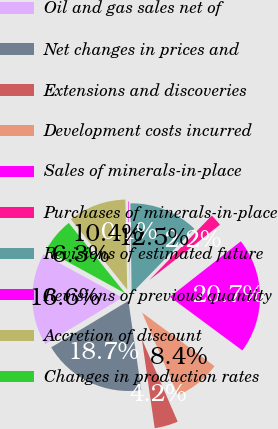Convert chart to OTSL. <chart><loc_0><loc_0><loc_500><loc_500><pie_chart><fcel>Oil and gas sales net of<fcel>Net changes in prices and<fcel>Extensions and discoveries<fcel>Development costs incurred<fcel>Sales of minerals-in-place<fcel>Purchases of minerals-in-place<fcel>Revisions of estimated future<fcel>Revisions of previous quantity<fcel>Accretion of discount<fcel>Changes in production rates<nl><fcel>16.59%<fcel>18.65%<fcel>4.23%<fcel>8.35%<fcel>20.71%<fcel>2.17%<fcel>12.47%<fcel>0.11%<fcel>10.41%<fcel>6.29%<nl></chart> 